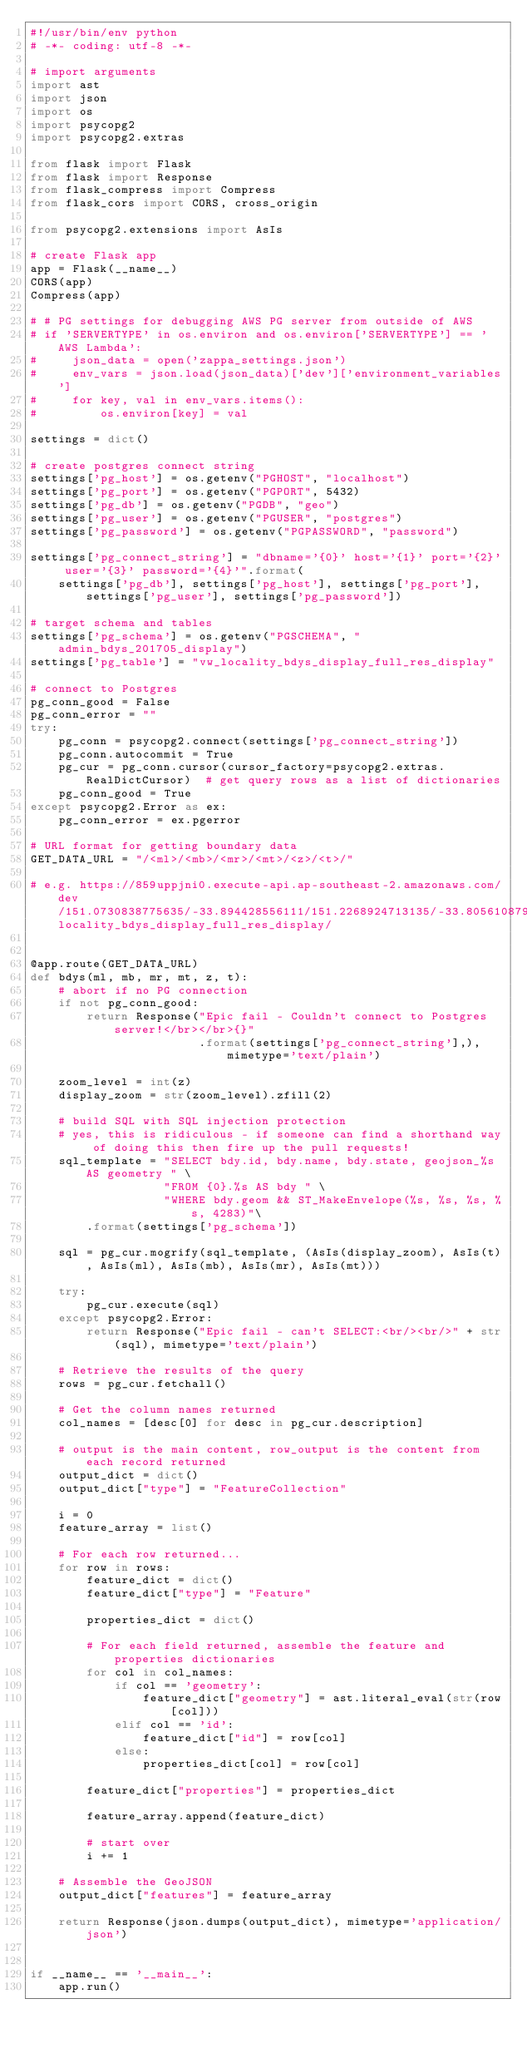<code> <loc_0><loc_0><loc_500><loc_500><_Python_>#!/usr/bin/env python
# -*- coding: utf-8 -*-

# import arguments
import ast
import json
import os
import psycopg2
import psycopg2.extras

from flask import Flask
from flask import Response
from flask_compress import Compress
from flask_cors import CORS, cross_origin

from psycopg2.extensions import AsIs

# create Flask app
app = Flask(__name__)
CORS(app)
Compress(app)

# # PG settings for debugging AWS PG server from outside of AWS
# if 'SERVERTYPE' in os.environ and os.environ['SERVERTYPE'] == 'AWS Lambda':
#     json_data = open('zappa_settings.json')
#     env_vars = json.load(json_data)['dev']['environment_variables']
#     for key, val in env_vars.items():
#         os.environ[key] = val

settings = dict()

# create postgres connect string
settings['pg_host'] = os.getenv("PGHOST", "localhost")
settings['pg_port'] = os.getenv("PGPORT", 5432)
settings['pg_db'] = os.getenv("PGDB", "geo")
settings['pg_user'] = os.getenv("PGUSER", "postgres")
settings['pg_password'] = os.getenv("PGPASSWORD", "password")

settings['pg_connect_string'] = "dbname='{0}' host='{1}' port='{2}' user='{3}' password='{4}'".format(
    settings['pg_db'], settings['pg_host'], settings['pg_port'], settings['pg_user'], settings['pg_password'])

# target schema and tables
settings['pg_schema'] = os.getenv("PGSCHEMA", "admin_bdys_201705_display")
settings['pg_table'] = "vw_locality_bdys_display_full_res_display"

# connect to Postgres
pg_conn_good = False
pg_conn_error = ""
try:
    pg_conn = psycopg2.connect(settings['pg_connect_string'])
    pg_conn.autocommit = True
    pg_cur = pg_conn.cursor(cursor_factory=psycopg2.extras.RealDictCursor)  # get query rows as a list of dictionaries
    pg_conn_good = True
except psycopg2.Error as ex:
    pg_conn_error = ex.pgerror

# URL format for getting boundary data
GET_DATA_URL = "/<ml>/<mb>/<mr>/<mt>/<z>/<t>/"

# e.g. https://859uppjni0.execute-api.ap-southeast-2.amazonaws.com/dev/151.0730838775635/-33.894428556111/151.2268924713135/-33.805610879310436/14/locality_bdys_display_full_res_display/


@app.route(GET_DATA_URL)
def bdys(ml, mb, mr, mt, z, t):
    # abort if no PG connection
    if not pg_conn_good:
        return Response("Epic fail - Couldn't connect to Postgres server!</br></br>{}"
                        .format(settings['pg_connect_string'],), mimetype='text/plain')

    zoom_level = int(z)
    display_zoom = str(zoom_level).zfill(2)

    # build SQL with SQL injection protection
    # yes, this is ridiculous - if someone can find a shorthand way of doing this then fire up the pull requests!
    sql_template = "SELECT bdy.id, bdy.name, bdy.state, geojson_%s AS geometry " \
                   "FROM {0}.%s AS bdy " \
                   "WHERE bdy.geom && ST_MakeEnvelope(%s, %s, %s, %s, 4283)"\
        .format(settings['pg_schema'])

    sql = pg_cur.mogrify(sql_template, (AsIs(display_zoom), AsIs(t), AsIs(ml), AsIs(mb), AsIs(mr), AsIs(mt)))

    try:
        pg_cur.execute(sql)
    except psycopg2.Error:
        return Response("Epic fail - can't SELECT:<br/><br/>" + str(sql), mimetype='text/plain')

    # Retrieve the results of the query
    rows = pg_cur.fetchall()

    # Get the column names returned
    col_names = [desc[0] for desc in pg_cur.description]

    # output is the main content, row_output is the content from each record returned
    output_dict = dict()
    output_dict["type"] = "FeatureCollection"

    i = 0
    feature_array = list()

    # For each row returned...
    for row in rows:
        feature_dict = dict()
        feature_dict["type"] = "Feature"

        properties_dict = dict()

        # For each field returned, assemble the feature and properties dictionaries
        for col in col_names:
            if col == 'geometry':
                feature_dict["geometry"] = ast.literal_eval(str(row[col]))
            elif col == 'id':
                feature_dict["id"] = row[col]
            else:
                properties_dict[col] = row[col]

        feature_dict["properties"] = properties_dict

        feature_array.append(feature_dict)

        # start over
        i += 1

    # Assemble the GeoJSON
    output_dict["features"] = feature_array

    return Response(json.dumps(output_dict), mimetype='application/json')


if __name__ == '__main__':
    app.run()
</code> 